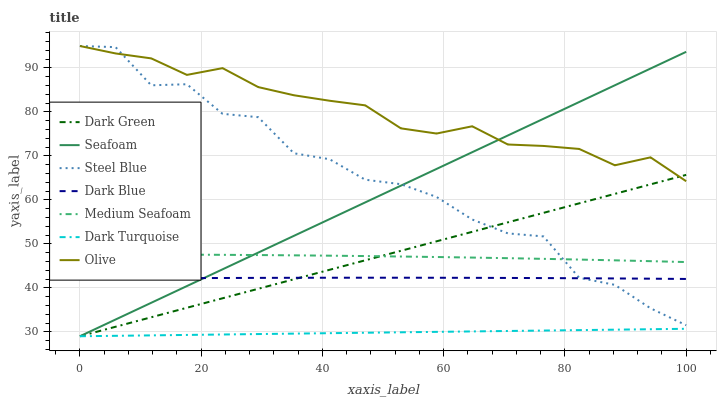Does Steel Blue have the minimum area under the curve?
Answer yes or no. No. Does Steel Blue have the maximum area under the curve?
Answer yes or no. No. Is Seafoam the smoothest?
Answer yes or no. No. Is Seafoam the roughest?
Answer yes or no. No. Does Steel Blue have the lowest value?
Answer yes or no. No. Does Seafoam have the highest value?
Answer yes or no. No. Is Dark Turquoise less than Olive?
Answer yes or no. Yes. Is Dark Blue greater than Dark Turquoise?
Answer yes or no. Yes. Does Dark Turquoise intersect Olive?
Answer yes or no. No. 